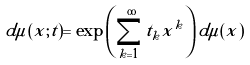Convert formula to latex. <formula><loc_0><loc_0><loc_500><loc_500>d \mu ( x ; t ) = \exp \left ( \sum _ { k = 1 } ^ { \infty } t _ { k } x ^ { k } \right ) d \mu ( x )</formula> 